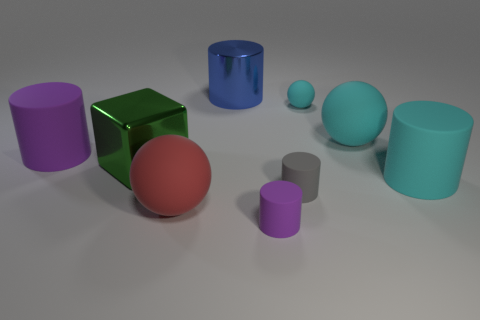What number of blue things are large shiny things or small rubber cubes?
Your answer should be very brief. 1. There is a large red object in front of the green block; is it the same shape as the thing on the left side of the large block?
Give a very brief answer. No. What number of other objects are there of the same material as the big green thing?
Ensure brevity in your answer.  1. Are there any shiny things that are left of the small matte thing that is in front of the ball that is to the left of the blue thing?
Offer a terse response. Yes. Are the big blue thing and the green block made of the same material?
Offer a terse response. Yes. Are there any other things that are the same shape as the small gray thing?
Your answer should be compact. Yes. What is the material of the object that is behind the small thing that is behind the cyan cylinder?
Your answer should be very brief. Metal. There is a purple matte cylinder that is behind the tiny gray rubber cylinder; what is its size?
Keep it short and to the point. Large. There is a matte cylinder that is to the left of the tiny gray matte cylinder and in front of the big purple cylinder; what is its color?
Offer a very short reply. Purple. Is the size of the green shiny cube in front of the blue cylinder the same as the big cyan cylinder?
Make the answer very short. Yes. 